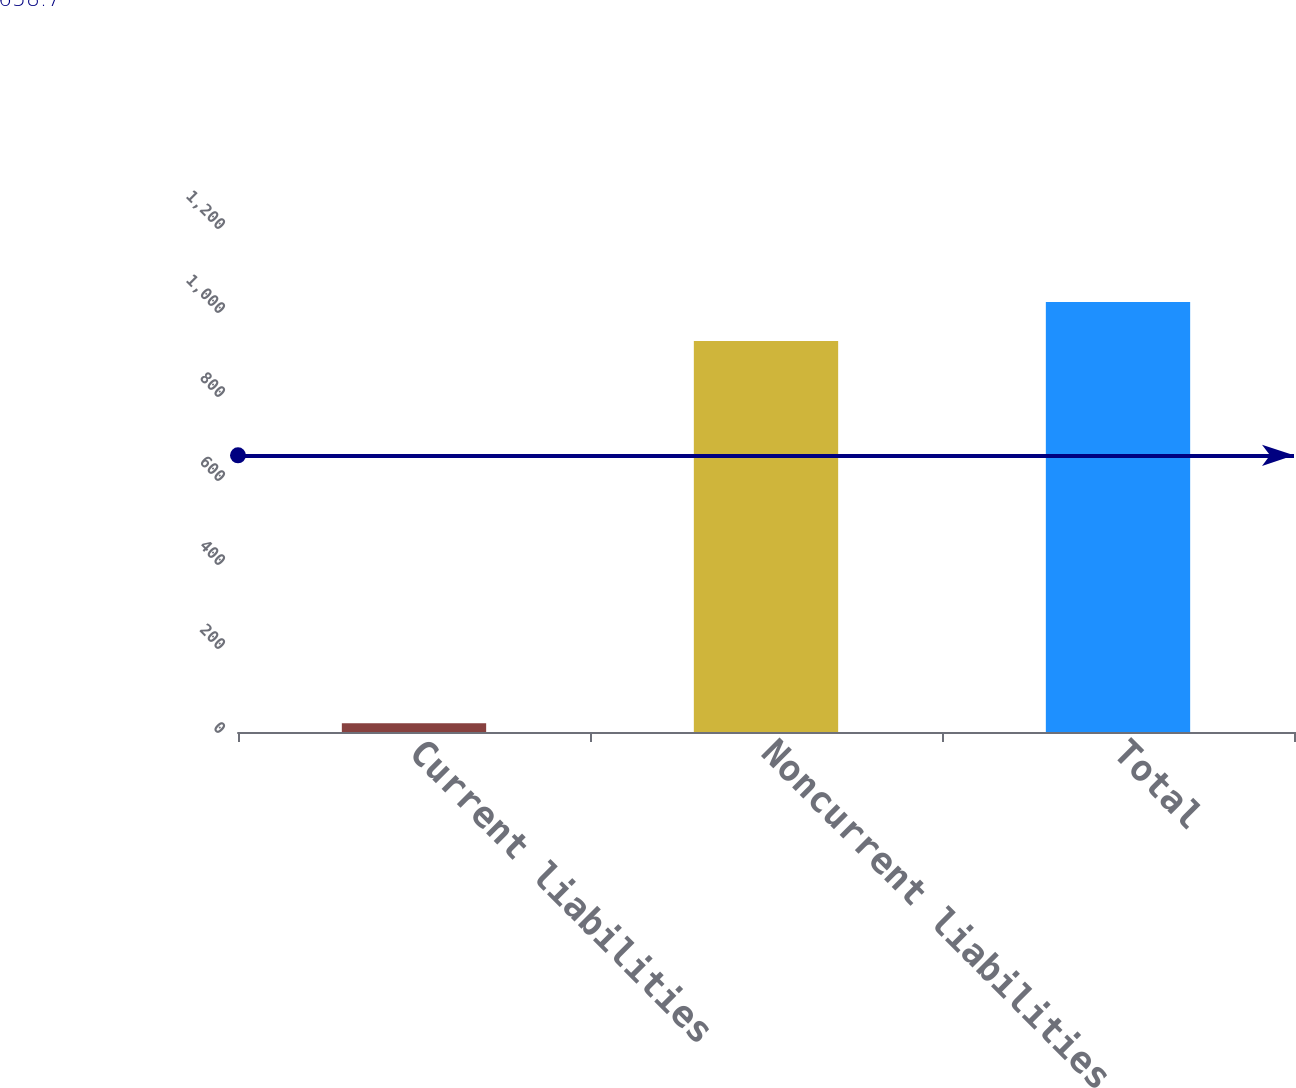Convert chart to OTSL. <chart><loc_0><loc_0><loc_500><loc_500><bar_chart><fcel>Current liabilities<fcel>Noncurrent liabilities<fcel>Total<nl><fcel>21<fcel>931<fcel>1024.1<nl></chart> 